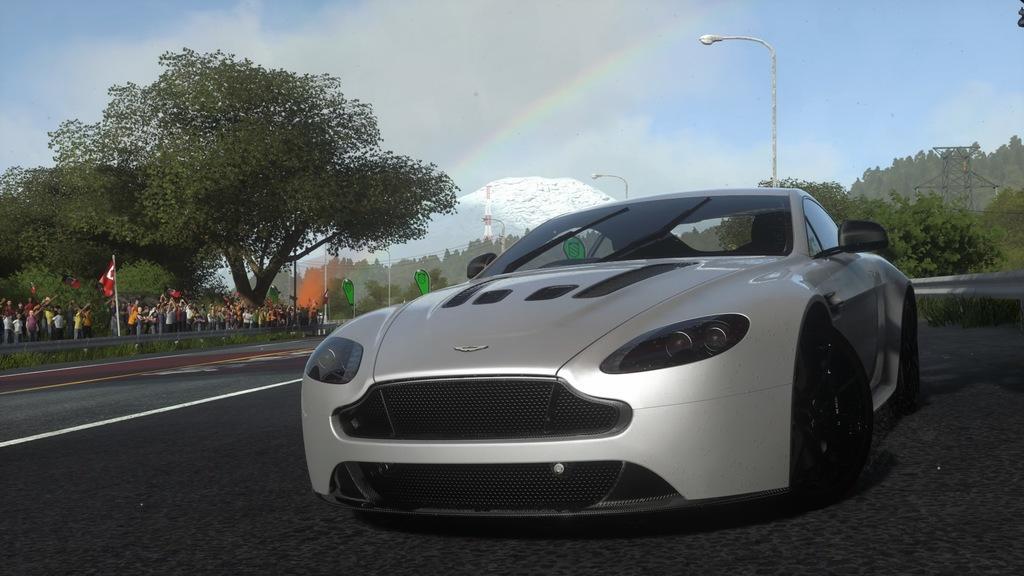How would you summarize this image in a sentence or two? In this picture, we can see a vehicle, road, ground with grass, trees, poles, lights, towers, fencing, the mountain, rainbow and the sky with clouds. 